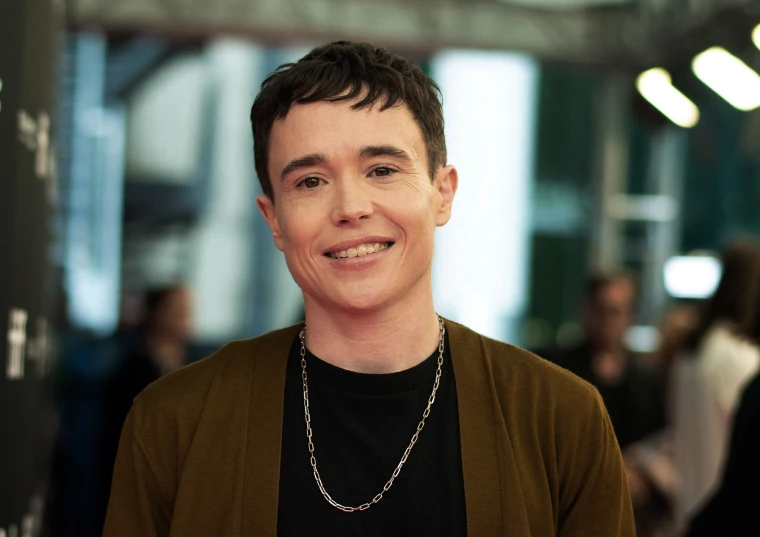Can you describe the fashion style of this person? The person is dressed in a refined yet approachable manner. Their ensemble includes a casual black shirt underneath a more formal brown blazer, striking a balance between relaxed and polished. The silver chain necklace adds a hint of personality and flair to the outfit. 